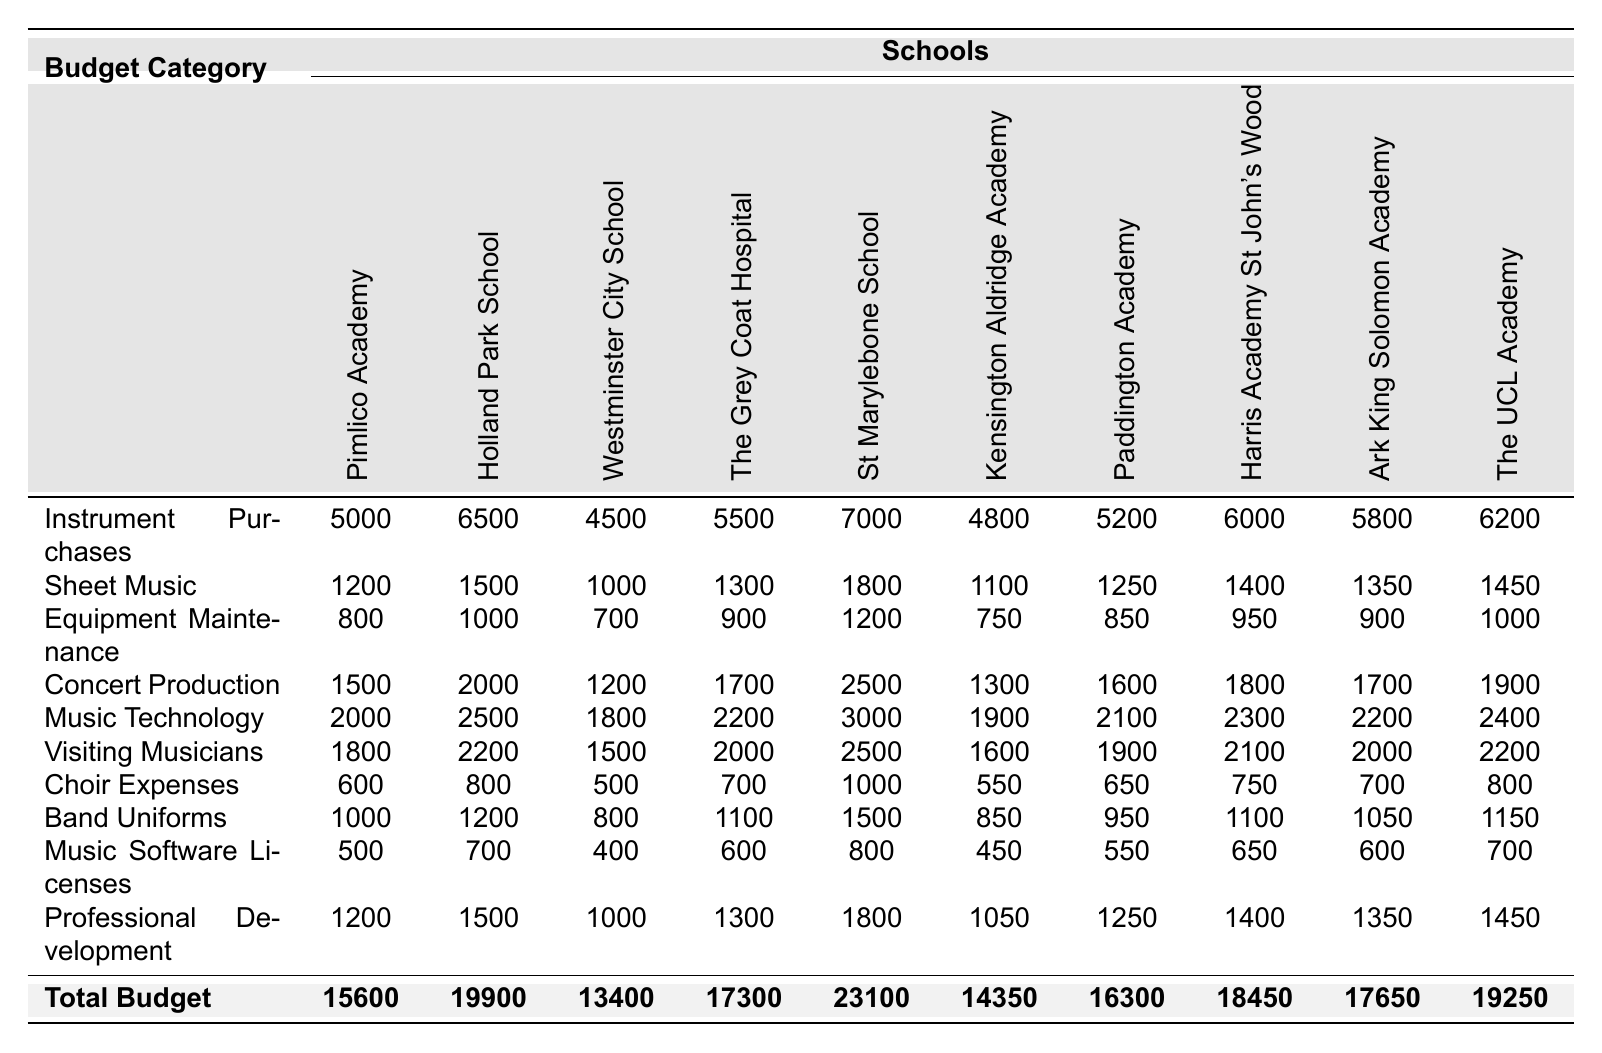What is the total budget allocation for Pimlico Academy? Looking at the last row where the total budgets are listed, Pimlico Academy's total budget allocation is clearly stated as 15,600.
Answer: 15600 Which school has the highest budget for Music Technology? By checking the Music Technology row, we see that St Marylebone School has the highest allocation at 3,000.
Answer: 3000 What is the combined budget for Choir Expenses across all schools? Summing the Choir Expenses values: 600 + 800 + 500 + 700 + 1,000 + 550 + 650 + 750 + 700 + 800 equals 5,000.
Answer: 5000 Is the budget allocation for Professional Development higher in The UCL Academy than in Westminster City School? The Professional Development allocation for The UCL Academy is 1,450, while Westminster City School is 1,000. Since 1,450 > 1,000, the statement is true.
Answer: Yes What is the average budget allocation for Equipment Maintenance across all schools? The Equipment Maintenance values are: 800, 1,000, 700, 900, 1,200, 750, 850, 950, 900, and 1,000. Summing these values gives 9,250, and dividing by 10 schools results in an average of 925.
Answer: 925 Which school spends the least on Band Uniforms? By checking the Band Uniforms row, we find that Westminster City School spends the least amount, which is 800.
Answer: 800 What is the budget difference for Concert Production between Holland Park School and Harris Academy St John's Wood? The allocation for Concert Production is 2,000 for Holland Park School and 1,800 for Harris Academy St John's Wood. The difference is 2,000 - 1,800, which equals 200.
Answer: 200 Does any school have the same budget allocation for Sheet Music? Checking the Sheet Music values, it shows that both Pimlico Academy and Westminster City School have an allocation of 1,200, hence they are the same.
Answer: Yes What is the total budget allocated to Instrument Purchases for all schools combined? Adding the Instrument Purchases: 5,000 + 6,500 + 4,500 + 5,500 + 7,000 + 4,800 + 5,200 + 6,000 + 5,800 + 6,200 gives a total of 56,000.
Answer: 56000 Which budget category has the greatest average allocation across all schools? First, calculate averages for each category: Instrument Purchases (5,600), Sheet Music (1,275), Equipment Maintenance (875), Concert Production (1,920), Music Technology (2,210), Visiting Musicians (1,925), Choir Expenses (700), Band Uniforms (1,025), Music Software Licenses (575), Professional Development (1,350). The highest average is for Music Technology at 2,210.
Answer: Music Technology 